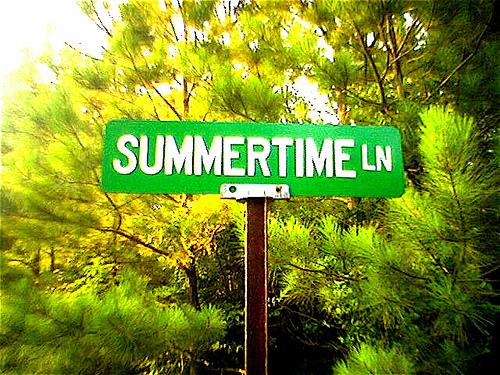How many street names are shown?
Write a very short answer. 1. What color is the writing on the sign?
Be succinct. White. What Avenue is shown?
Short answer required. Summertime. What is the name on the sign?
Give a very brief answer. Summertime ln. Is this in a city?
Keep it brief. No. What is behind the sign?
Give a very brief answer. Trees. What is the color of the sign?
Give a very brief answer. Green. How many trees are shown?
Concise answer only. 3. How many street signs are on the pole?
Quick response, please. 1. 